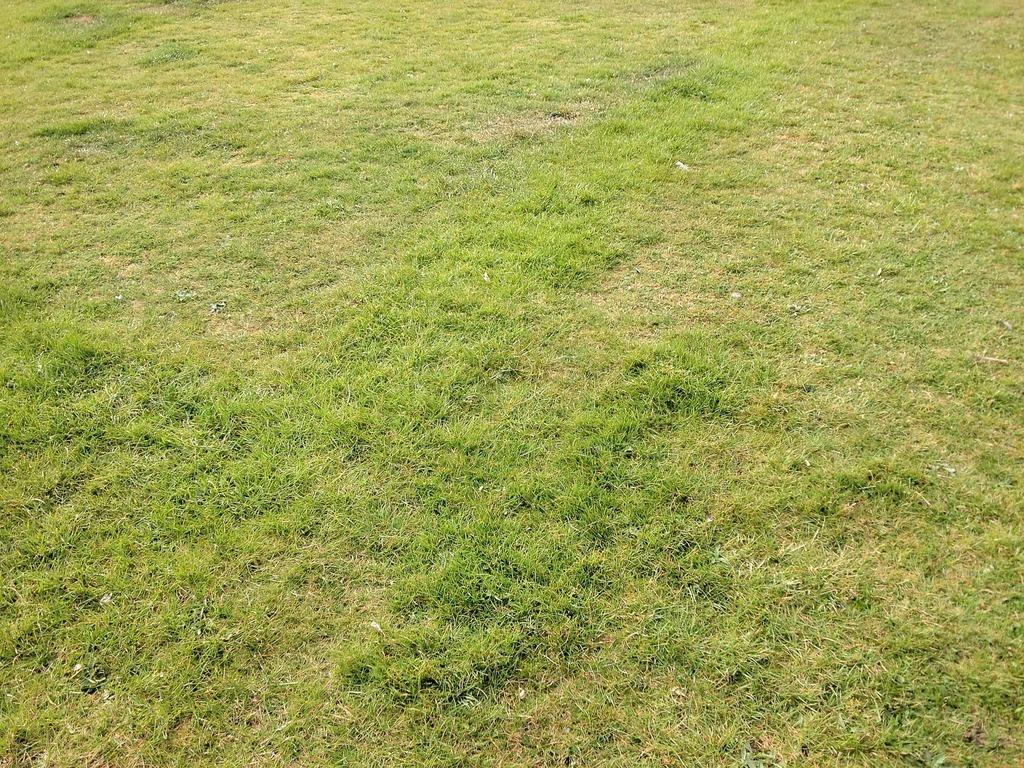Can you describe this image briefly? In this picture I can see the green grass on the ground. 